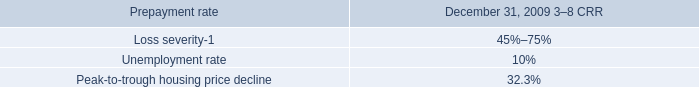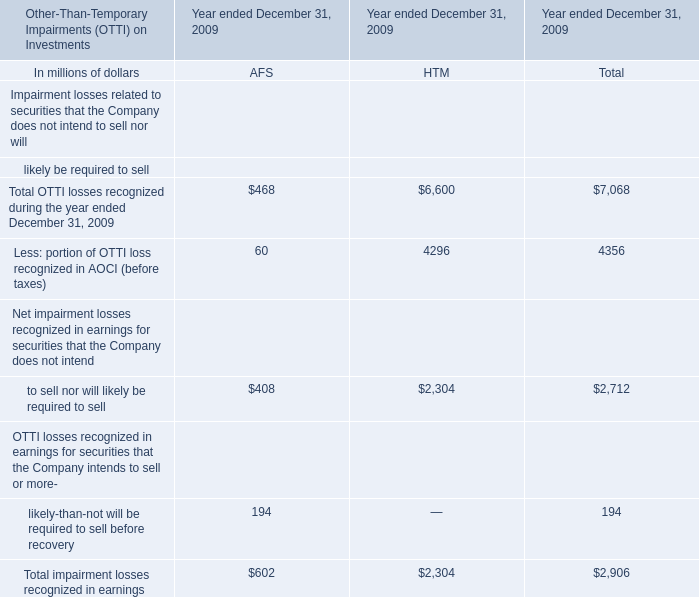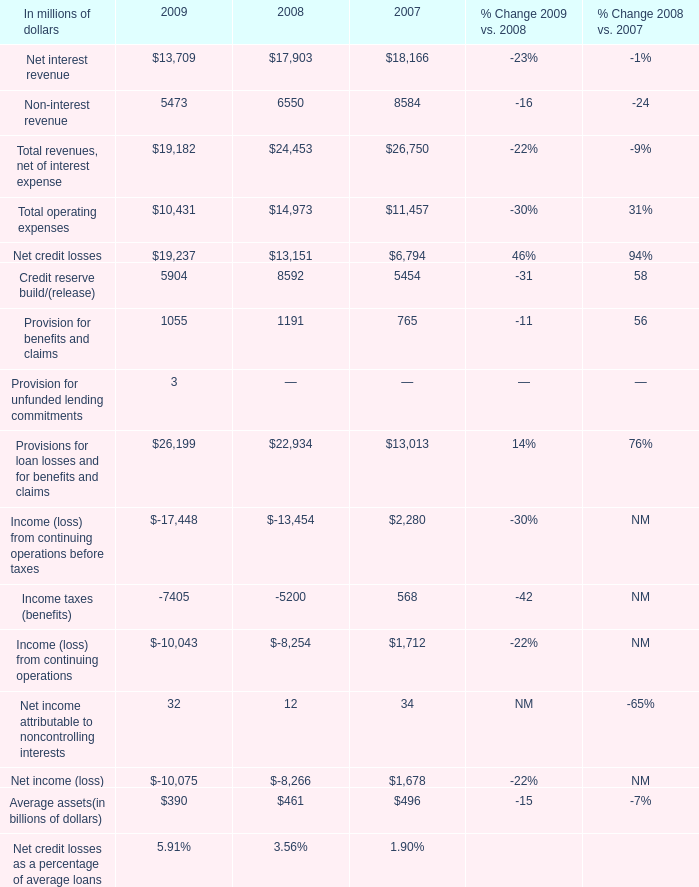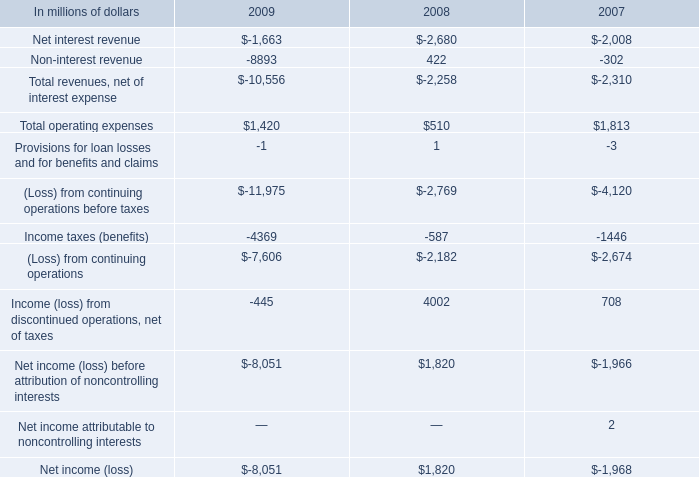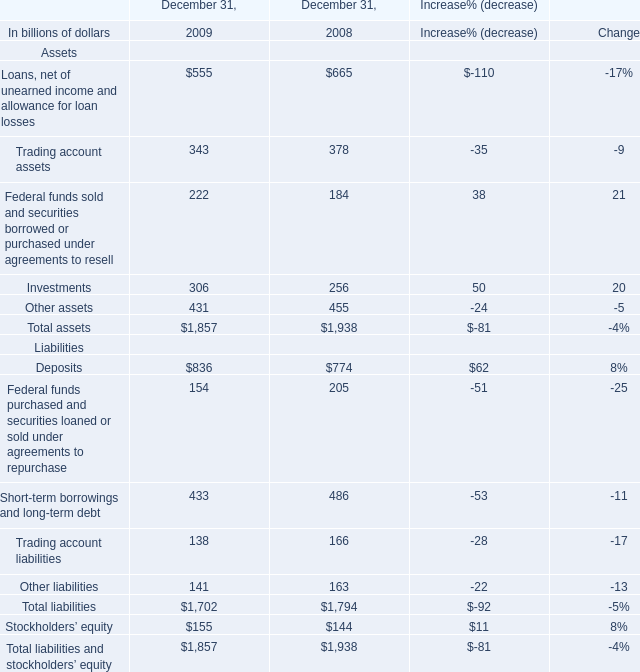In the year with the greatest proportion of investment, what is the proportion of investment to the tatol? 
Computations: (306 / 1857)
Answer: 0.16478. 